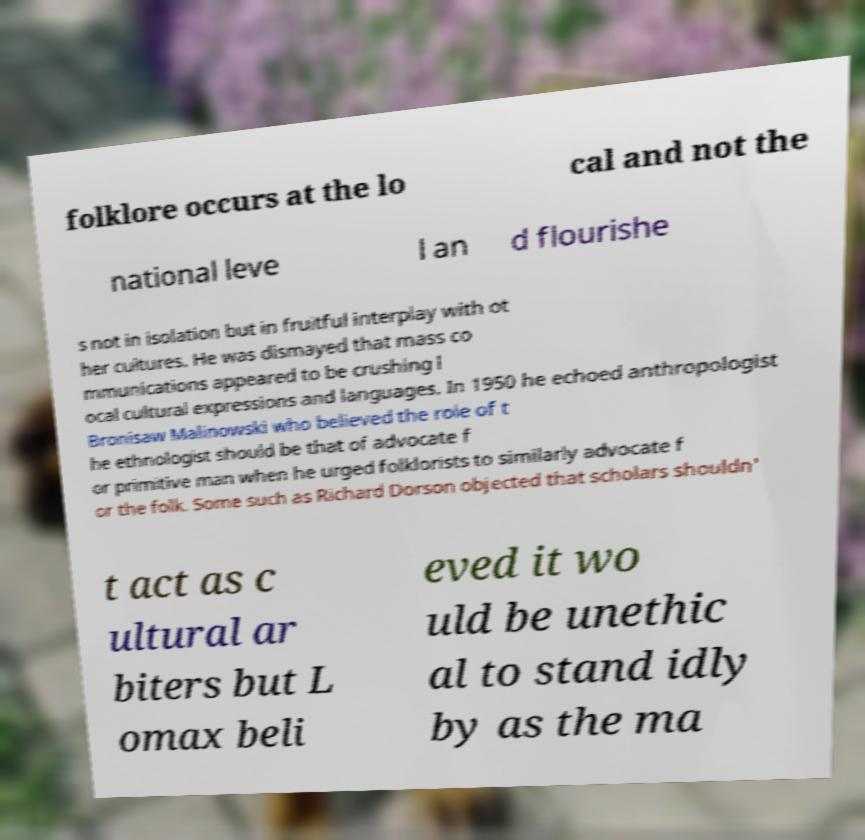There's text embedded in this image that I need extracted. Can you transcribe it verbatim? folklore occurs at the lo cal and not the national leve l an d flourishe s not in isolation but in fruitful interplay with ot her cultures. He was dismayed that mass co mmunications appeared to be crushing l ocal cultural expressions and languages. In 1950 he echoed anthropologist Bronisaw Malinowski who believed the role of t he ethnologist should be that of advocate f or primitive man when he urged folklorists to similarly advocate f or the folk. Some such as Richard Dorson objected that scholars shouldn' t act as c ultural ar biters but L omax beli eved it wo uld be unethic al to stand idly by as the ma 